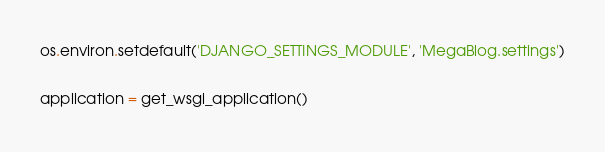<code> <loc_0><loc_0><loc_500><loc_500><_Python_>os.environ.setdefault('DJANGO_SETTINGS_MODULE', 'MegaBlog.settings')

application = get_wsgi_application()
</code> 